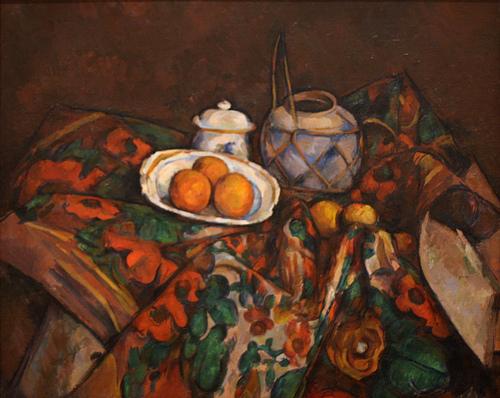What fruit is shown here?
Write a very short answer. Orange. Painting or real life?
Concise answer only. Painting. How many oranges are there?
Answer briefly. 3. 